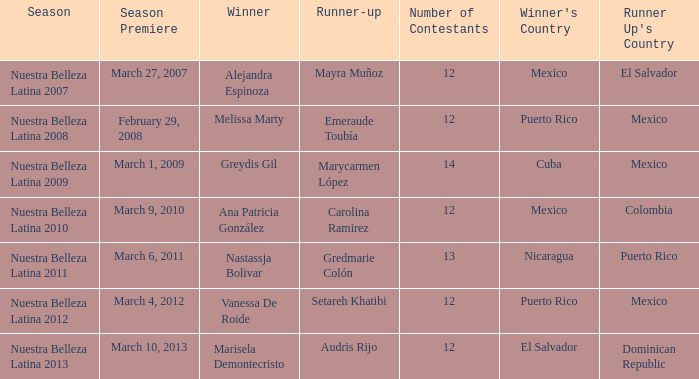How many contestants were there on March 1, 2009 during the season premiere? 14.0. 